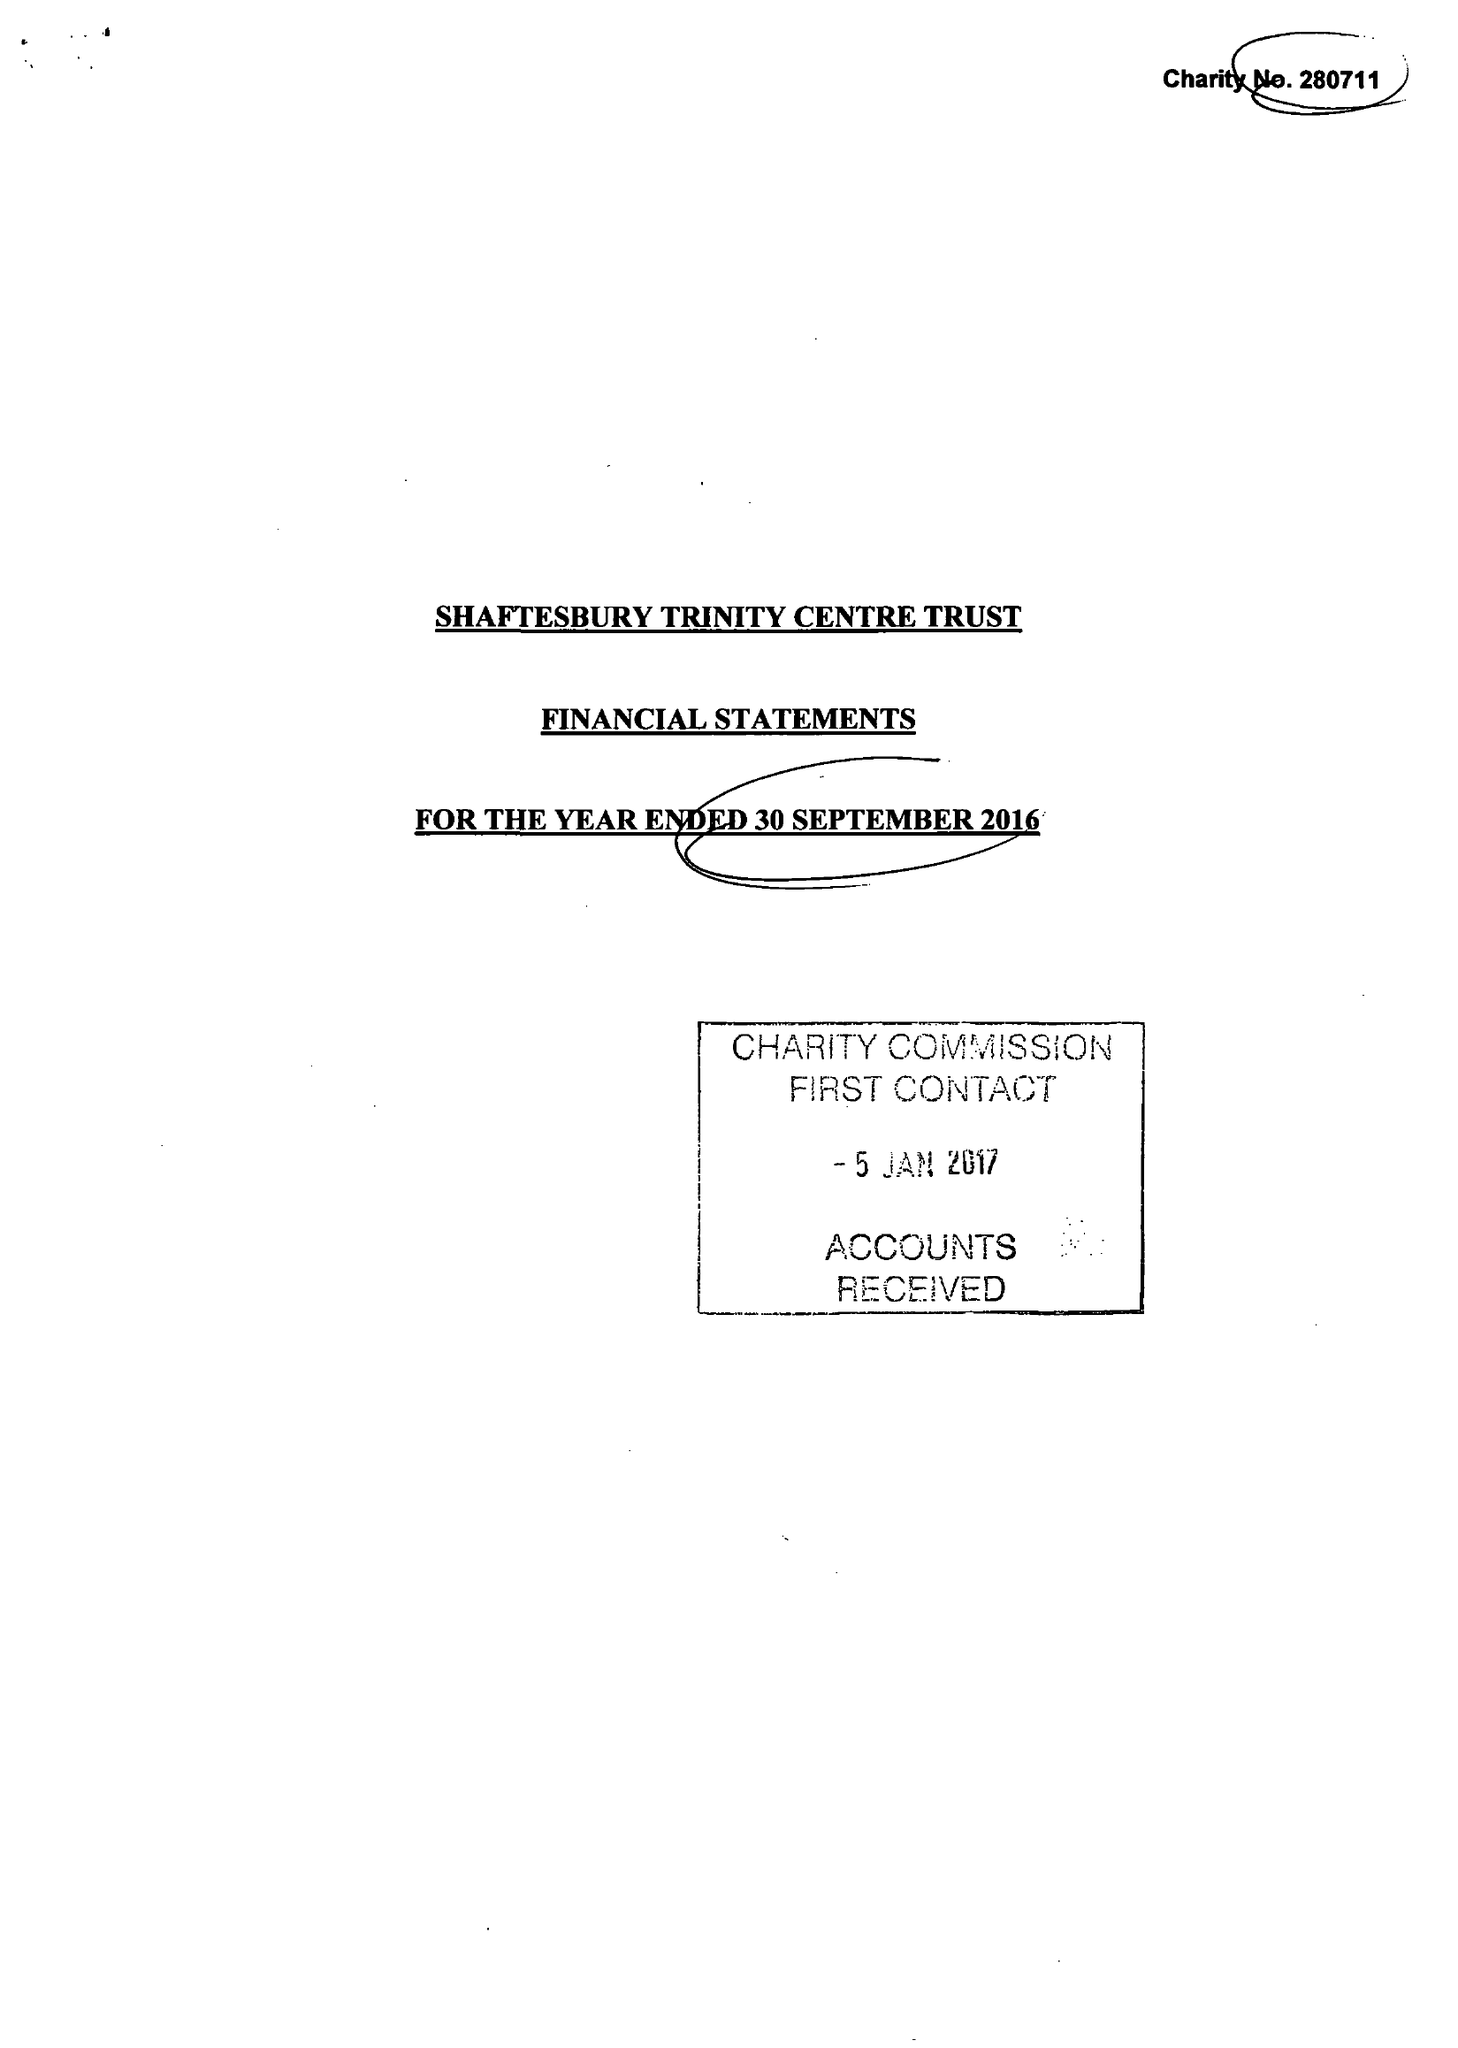What is the value for the charity_name?
Answer the question using a single word or phrase. Shaftesbury Trinity Centre Trust 